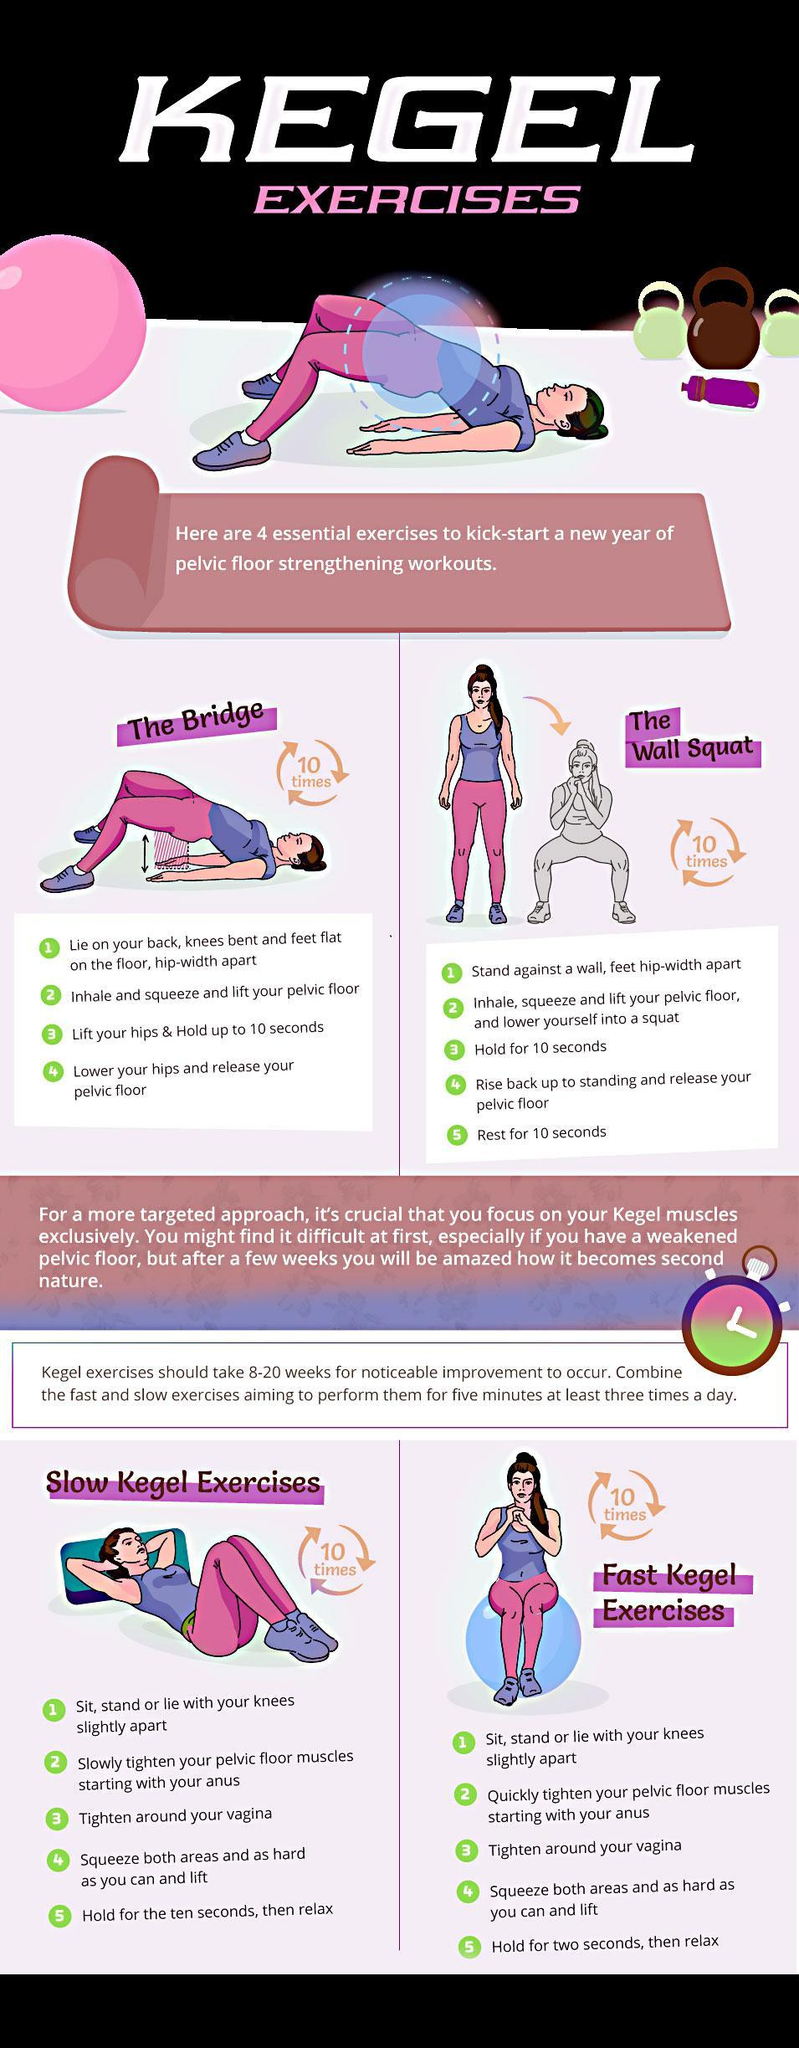Which step needs to be done after the second step in the wall squat?
Answer the question with a short phrase. Hold for 10 secs How many times should each of the exercise be repeated, 3 times, 10 times, or 5 times? 10 times Which Kegel exercises have a hold time of 10 seconds? 3 